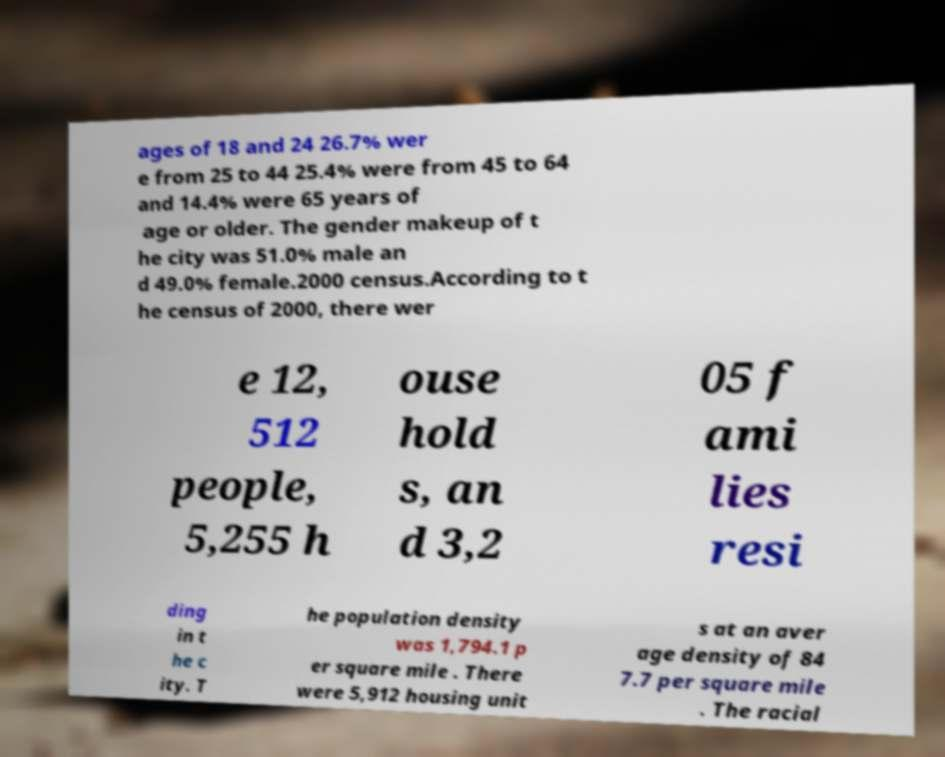Could you extract and type out the text from this image? ages of 18 and 24 26.7% wer e from 25 to 44 25.4% were from 45 to 64 and 14.4% were 65 years of age or older. The gender makeup of t he city was 51.0% male an d 49.0% female.2000 census.According to t he census of 2000, there wer e 12, 512 people, 5,255 h ouse hold s, an d 3,2 05 f ami lies resi ding in t he c ity. T he population density was 1,794.1 p er square mile . There were 5,912 housing unit s at an aver age density of 84 7.7 per square mile . The racial 